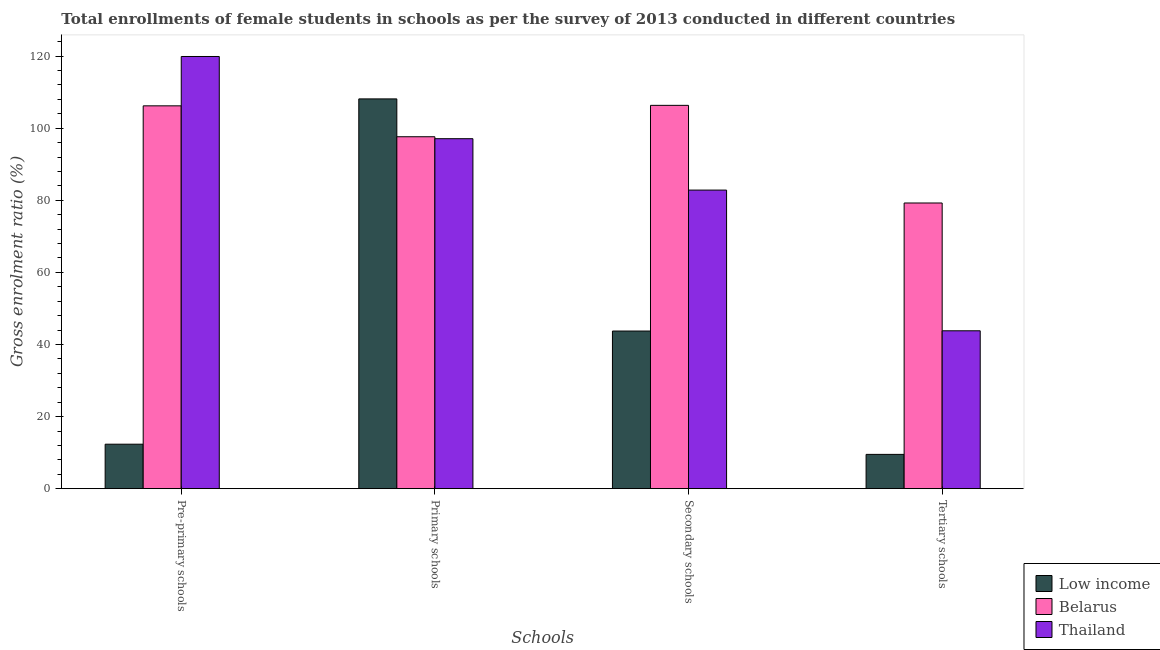How many groups of bars are there?
Provide a succinct answer. 4. How many bars are there on the 2nd tick from the left?
Provide a short and direct response. 3. How many bars are there on the 2nd tick from the right?
Provide a succinct answer. 3. What is the label of the 2nd group of bars from the left?
Provide a short and direct response. Primary schools. What is the gross enrolment ratio(female) in pre-primary schools in Low income?
Keep it short and to the point. 12.34. Across all countries, what is the maximum gross enrolment ratio(female) in pre-primary schools?
Provide a short and direct response. 119.9. Across all countries, what is the minimum gross enrolment ratio(female) in secondary schools?
Give a very brief answer. 43.73. In which country was the gross enrolment ratio(female) in pre-primary schools maximum?
Make the answer very short. Thailand. What is the total gross enrolment ratio(female) in secondary schools in the graph?
Make the answer very short. 232.91. What is the difference between the gross enrolment ratio(female) in tertiary schools in Low income and that in Belarus?
Your answer should be very brief. -69.74. What is the difference between the gross enrolment ratio(female) in primary schools in Low income and the gross enrolment ratio(female) in tertiary schools in Belarus?
Offer a terse response. 28.88. What is the average gross enrolment ratio(female) in pre-primary schools per country?
Keep it short and to the point. 79.48. What is the difference between the gross enrolment ratio(female) in primary schools and gross enrolment ratio(female) in tertiary schools in Thailand?
Make the answer very short. 53.29. In how many countries, is the gross enrolment ratio(female) in tertiary schools greater than 108 %?
Provide a succinct answer. 0. What is the ratio of the gross enrolment ratio(female) in primary schools in Thailand to that in Belarus?
Your response must be concise. 0.99. Is the gross enrolment ratio(female) in primary schools in Thailand less than that in Belarus?
Keep it short and to the point. Yes. Is the difference between the gross enrolment ratio(female) in pre-primary schools in Belarus and Low income greater than the difference between the gross enrolment ratio(female) in tertiary schools in Belarus and Low income?
Offer a terse response. Yes. What is the difference between the highest and the second highest gross enrolment ratio(female) in tertiary schools?
Your answer should be very brief. 35.45. What is the difference between the highest and the lowest gross enrolment ratio(female) in secondary schools?
Offer a terse response. 62.61. What does the 1st bar from the left in Secondary schools represents?
Ensure brevity in your answer.  Low income. What does the 2nd bar from the right in Tertiary schools represents?
Provide a short and direct response. Belarus. Is it the case that in every country, the sum of the gross enrolment ratio(female) in pre-primary schools and gross enrolment ratio(female) in primary schools is greater than the gross enrolment ratio(female) in secondary schools?
Your answer should be very brief. Yes. How many bars are there?
Offer a terse response. 12. Are all the bars in the graph horizontal?
Give a very brief answer. No. Are the values on the major ticks of Y-axis written in scientific E-notation?
Provide a succinct answer. No. Where does the legend appear in the graph?
Keep it short and to the point. Bottom right. How are the legend labels stacked?
Provide a succinct answer. Vertical. What is the title of the graph?
Ensure brevity in your answer.  Total enrollments of female students in schools as per the survey of 2013 conducted in different countries. What is the label or title of the X-axis?
Keep it short and to the point. Schools. What is the label or title of the Y-axis?
Your answer should be compact. Gross enrolment ratio (%). What is the Gross enrolment ratio (%) of Low income in Pre-primary schools?
Your answer should be compact. 12.34. What is the Gross enrolment ratio (%) in Belarus in Pre-primary schools?
Offer a terse response. 106.21. What is the Gross enrolment ratio (%) in Thailand in Pre-primary schools?
Ensure brevity in your answer.  119.9. What is the Gross enrolment ratio (%) in Low income in Primary schools?
Keep it short and to the point. 108.14. What is the Gross enrolment ratio (%) in Belarus in Primary schools?
Offer a terse response. 97.63. What is the Gross enrolment ratio (%) of Thailand in Primary schools?
Give a very brief answer. 97.09. What is the Gross enrolment ratio (%) of Low income in Secondary schools?
Ensure brevity in your answer.  43.73. What is the Gross enrolment ratio (%) of Belarus in Secondary schools?
Your response must be concise. 106.34. What is the Gross enrolment ratio (%) of Thailand in Secondary schools?
Your answer should be very brief. 82.84. What is the Gross enrolment ratio (%) in Low income in Tertiary schools?
Your answer should be compact. 9.51. What is the Gross enrolment ratio (%) of Belarus in Tertiary schools?
Make the answer very short. 79.26. What is the Gross enrolment ratio (%) in Thailand in Tertiary schools?
Make the answer very short. 43.8. Across all Schools, what is the maximum Gross enrolment ratio (%) in Low income?
Your response must be concise. 108.14. Across all Schools, what is the maximum Gross enrolment ratio (%) of Belarus?
Provide a short and direct response. 106.34. Across all Schools, what is the maximum Gross enrolment ratio (%) in Thailand?
Keep it short and to the point. 119.9. Across all Schools, what is the minimum Gross enrolment ratio (%) of Low income?
Offer a very short reply. 9.51. Across all Schools, what is the minimum Gross enrolment ratio (%) of Belarus?
Offer a very short reply. 79.26. Across all Schools, what is the minimum Gross enrolment ratio (%) in Thailand?
Provide a succinct answer. 43.8. What is the total Gross enrolment ratio (%) in Low income in the graph?
Keep it short and to the point. 173.72. What is the total Gross enrolment ratio (%) of Belarus in the graph?
Give a very brief answer. 389.44. What is the total Gross enrolment ratio (%) in Thailand in the graph?
Make the answer very short. 343.63. What is the difference between the Gross enrolment ratio (%) in Low income in Pre-primary schools and that in Primary schools?
Your response must be concise. -95.8. What is the difference between the Gross enrolment ratio (%) of Belarus in Pre-primary schools and that in Primary schools?
Provide a succinct answer. 8.58. What is the difference between the Gross enrolment ratio (%) of Thailand in Pre-primary schools and that in Primary schools?
Give a very brief answer. 22.81. What is the difference between the Gross enrolment ratio (%) of Low income in Pre-primary schools and that in Secondary schools?
Your answer should be compact. -31.39. What is the difference between the Gross enrolment ratio (%) of Belarus in Pre-primary schools and that in Secondary schools?
Offer a terse response. -0.13. What is the difference between the Gross enrolment ratio (%) of Thailand in Pre-primary schools and that in Secondary schools?
Offer a terse response. 37.06. What is the difference between the Gross enrolment ratio (%) of Low income in Pre-primary schools and that in Tertiary schools?
Provide a succinct answer. 2.83. What is the difference between the Gross enrolment ratio (%) in Belarus in Pre-primary schools and that in Tertiary schools?
Offer a very short reply. 26.95. What is the difference between the Gross enrolment ratio (%) of Thailand in Pre-primary schools and that in Tertiary schools?
Offer a terse response. 76.1. What is the difference between the Gross enrolment ratio (%) in Low income in Primary schools and that in Secondary schools?
Ensure brevity in your answer.  64.4. What is the difference between the Gross enrolment ratio (%) in Belarus in Primary schools and that in Secondary schools?
Give a very brief answer. -8.71. What is the difference between the Gross enrolment ratio (%) of Thailand in Primary schools and that in Secondary schools?
Give a very brief answer. 14.26. What is the difference between the Gross enrolment ratio (%) of Low income in Primary schools and that in Tertiary schools?
Provide a succinct answer. 98.62. What is the difference between the Gross enrolment ratio (%) of Belarus in Primary schools and that in Tertiary schools?
Offer a very short reply. 18.38. What is the difference between the Gross enrolment ratio (%) of Thailand in Primary schools and that in Tertiary schools?
Keep it short and to the point. 53.29. What is the difference between the Gross enrolment ratio (%) in Low income in Secondary schools and that in Tertiary schools?
Offer a terse response. 34.22. What is the difference between the Gross enrolment ratio (%) of Belarus in Secondary schools and that in Tertiary schools?
Make the answer very short. 27.09. What is the difference between the Gross enrolment ratio (%) of Thailand in Secondary schools and that in Tertiary schools?
Offer a very short reply. 39.03. What is the difference between the Gross enrolment ratio (%) of Low income in Pre-primary schools and the Gross enrolment ratio (%) of Belarus in Primary schools?
Make the answer very short. -85.29. What is the difference between the Gross enrolment ratio (%) of Low income in Pre-primary schools and the Gross enrolment ratio (%) of Thailand in Primary schools?
Offer a very short reply. -84.75. What is the difference between the Gross enrolment ratio (%) in Belarus in Pre-primary schools and the Gross enrolment ratio (%) in Thailand in Primary schools?
Your response must be concise. 9.12. What is the difference between the Gross enrolment ratio (%) of Low income in Pre-primary schools and the Gross enrolment ratio (%) of Belarus in Secondary schools?
Your response must be concise. -94. What is the difference between the Gross enrolment ratio (%) in Low income in Pre-primary schools and the Gross enrolment ratio (%) in Thailand in Secondary schools?
Offer a terse response. -70.5. What is the difference between the Gross enrolment ratio (%) of Belarus in Pre-primary schools and the Gross enrolment ratio (%) of Thailand in Secondary schools?
Make the answer very short. 23.37. What is the difference between the Gross enrolment ratio (%) in Low income in Pre-primary schools and the Gross enrolment ratio (%) in Belarus in Tertiary schools?
Your answer should be compact. -66.92. What is the difference between the Gross enrolment ratio (%) in Low income in Pre-primary schools and the Gross enrolment ratio (%) in Thailand in Tertiary schools?
Make the answer very short. -31.46. What is the difference between the Gross enrolment ratio (%) of Belarus in Pre-primary schools and the Gross enrolment ratio (%) of Thailand in Tertiary schools?
Keep it short and to the point. 62.41. What is the difference between the Gross enrolment ratio (%) of Low income in Primary schools and the Gross enrolment ratio (%) of Belarus in Secondary schools?
Make the answer very short. 1.79. What is the difference between the Gross enrolment ratio (%) in Low income in Primary schools and the Gross enrolment ratio (%) in Thailand in Secondary schools?
Ensure brevity in your answer.  25.3. What is the difference between the Gross enrolment ratio (%) in Belarus in Primary schools and the Gross enrolment ratio (%) in Thailand in Secondary schools?
Keep it short and to the point. 14.8. What is the difference between the Gross enrolment ratio (%) of Low income in Primary schools and the Gross enrolment ratio (%) of Belarus in Tertiary schools?
Ensure brevity in your answer.  28.88. What is the difference between the Gross enrolment ratio (%) in Low income in Primary schools and the Gross enrolment ratio (%) in Thailand in Tertiary schools?
Provide a succinct answer. 64.33. What is the difference between the Gross enrolment ratio (%) of Belarus in Primary schools and the Gross enrolment ratio (%) of Thailand in Tertiary schools?
Keep it short and to the point. 53.83. What is the difference between the Gross enrolment ratio (%) of Low income in Secondary schools and the Gross enrolment ratio (%) of Belarus in Tertiary schools?
Make the answer very short. -35.52. What is the difference between the Gross enrolment ratio (%) in Low income in Secondary schools and the Gross enrolment ratio (%) in Thailand in Tertiary schools?
Your answer should be very brief. -0.07. What is the difference between the Gross enrolment ratio (%) in Belarus in Secondary schools and the Gross enrolment ratio (%) in Thailand in Tertiary schools?
Offer a terse response. 62.54. What is the average Gross enrolment ratio (%) in Low income per Schools?
Provide a short and direct response. 43.43. What is the average Gross enrolment ratio (%) of Belarus per Schools?
Provide a short and direct response. 97.36. What is the average Gross enrolment ratio (%) in Thailand per Schools?
Offer a very short reply. 85.91. What is the difference between the Gross enrolment ratio (%) in Low income and Gross enrolment ratio (%) in Belarus in Pre-primary schools?
Offer a very short reply. -93.87. What is the difference between the Gross enrolment ratio (%) in Low income and Gross enrolment ratio (%) in Thailand in Pre-primary schools?
Offer a terse response. -107.56. What is the difference between the Gross enrolment ratio (%) in Belarus and Gross enrolment ratio (%) in Thailand in Pre-primary schools?
Offer a very short reply. -13.69. What is the difference between the Gross enrolment ratio (%) of Low income and Gross enrolment ratio (%) of Belarus in Primary schools?
Your answer should be very brief. 10.5. What is the difference between the Gross enrolment ratio (%) of Low income and Gross enrolment ratio (%) of Thailand in Primary schools?
Make the answer very short. 11.04. What is the difference between the Gross enrolment ratio (%) in Belarus and Gross enrolment ratio (%) in Thailand in Primary schools?
Give a very brief answer. 0.54. What is the difference between the Gross enrolment ratio (%) in Low income and Gross enrolment ratio (%) in Belarus in Secondary schools?
Your answer should be compact. -62.61. What is the difference between the Gross enrolment ratio (%) of Low income and Gross enrolment ratio (%) of Thailand in Secondary schools?
Your response must be concise. -39.1. What is the difference between the Gross enrolment ratio (%) of Belarus and Gross enrolment ratio (%) of Thailand in Secondary schools?
Your response must be concise. 23.51. What is the difference between the Gross enrolment ratio (%) of Low income and Gross enrolment ratio (%) of Belarus in Tertiary schools?
Your answer should be compact. -69.74. What is the difference between the Gross enrolment ratio (%) in Low income and Gross enrolment ratio (%) in Thailand in Tertiary schools?
Keep it short and to the point. -34.29. What is the difference between the Gross enrolment ratio (%) in Belarus and Gross enrolment ratio (%) in Thailand in Tertiary schools?
Your response must be concise. 35.45. What is the ratio of the Gross enrolment ratio (%) of Low income in Pre-primary schools to that in Primary schools?
Your answer should be compact. 0.11. What is the ratio of the Gross enrolment ratio (%) of Belarus in Pre-primary schools to that in Primary schools?
Provide a short and direct response. 1.09. What is the ratio of the Gross enrolment ratio (%) in Thailand in Pre-primary schools to that in Primary schools?
Make the answer very short. 1.23. What is the ratio of the Gross enrolment ratio (%) of Low income in Pre-primary schools to that in Secondary schools?
Your answer should be compact. 0.28. What is the ratio of the Gross enrolment ratio (%) in Thailand in Pre-primary schools to that in Secondary schools?
Make the answer very short. 1.45. What is the ratio of the Gross enrolment ratio (%) in Low income in Pre-primary schools to that in Tertiary schools?
Keep it short and to the point. 1.3. What is the ratio of the Gross enrolment ratio (%) of Belarus in Pre-primary schools to that in Tertiary schools?
Provide a short and direct response. 1.34. What is the ratio of the Gross enrolment ratio (%) of Thailand in Pre-primary schools to that in Tertiary schools?
Give a very brief answer. 2.74. What is the ratio of the Gross enrolment ratio (%) of Low income in Primary schools to that in Secondary schools?
Ensure brevity in your answer.  2.47. What is the ratio of the Gross enrolment ratio (%) of Belarus in Primary schools to that in Secondary schools?
Ensure brevity in your answer.  0.92. What is the ratio of the Gross enrolment ratio (%) in Thailand in Primary schools to that in Secondary schools?
Ensure brevity in your answer.  1.17. What is the ratio of the Gross enrolment ratio (%) in Low income in Primary schools to that in Tertiary schools?
Your answer should be very brief. 11.37. What is the ratio of the Gross enrolment ratio (%) of Belarus in Primary schools to that in Tertiary schools?
Provide a succinct answer. 1.23. What is the ratio of the Gross enrolment ratio (%) of Thailand in Primary schools to that in Tertiary schools?
Provide a succinct answer. 2.22. What is the ratio of the Gross enrolment ratio (%) of Low income in Secondary schools to that in Tertiary schools?
Give a very brief answer. 4.6. What is the ratio of the Gross enrolment ratio (%) in Belarus in Secondary schools to that in Tertiary schools?
Offer a terse response. 1.34. What is the ratio of the Gross enrolment ratio (%) in Thailand in Secondary schools to that in Tertiary schools?
Your answer should be compact. 1.89. What is the difference between the highest and the second highest Gross enrolment ratio (%) in Low income?
Make the answer very short. 64.4. What is the difference between the highest and the second highest Gross enrolment ratio (%) in Belarus?
Offer a terse response. 0.13. What is the difference between the highest and the second highest Gross enrolment ratio (%) in Thailand?
Your answer should be very brief. 22.81. What is the difference between the highest and the lowest Gross enrolment ratio (%) in Low income?
Offer a terse response. 98.62. What is the difference between the highest and the lowest Gross enrolment ratio (%) in Belarus?
Provide a succinct answer. 27.09. What is the difference between the highest and the lowest Gross enrolment ratio (%) of Thailand?
Provide a short and direct response. 76.1. 